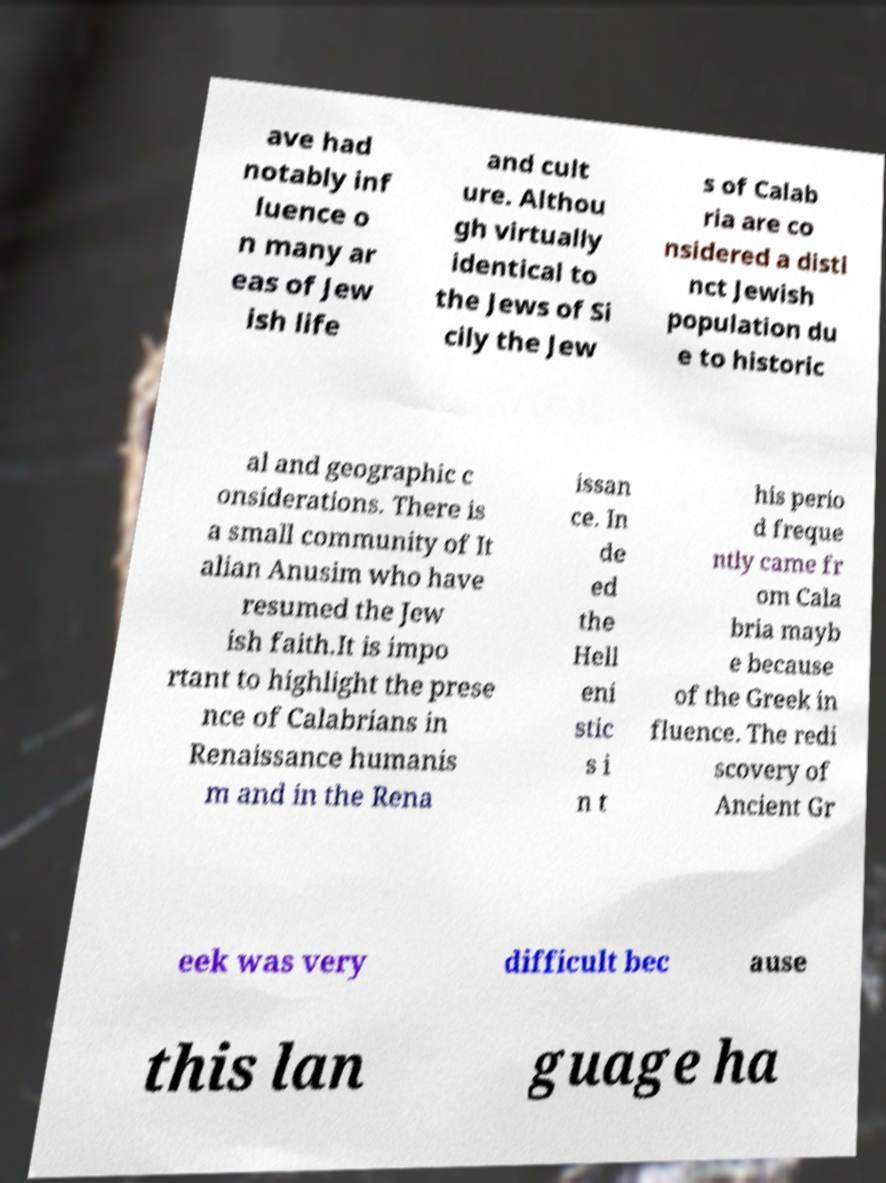I need the written content from this picture converted into text. Can you do that? ave had notably inf luence o n many ar eas of Jew ish life and cult ure. Althou gh virtually identical to the Jews of Si cily the Jew s of Calab ria are co nsidered a disti nct Jewish population du e to historic al and geographic c onsiderations. There is a small community of It alian Anusim who have resumed the Jew ish faith.It is impo rtant to highlight the prese nce of Calabrians in Renaissance humanis m and in the Rena issan ce. In de ed the Hell eni stic s i n t his perio d freque ntly came fr om Cala bria mayb e because of the Greek in fluence. The redi scovery of Ancient Gr eek was very difficult bec ause this lan guage ha 